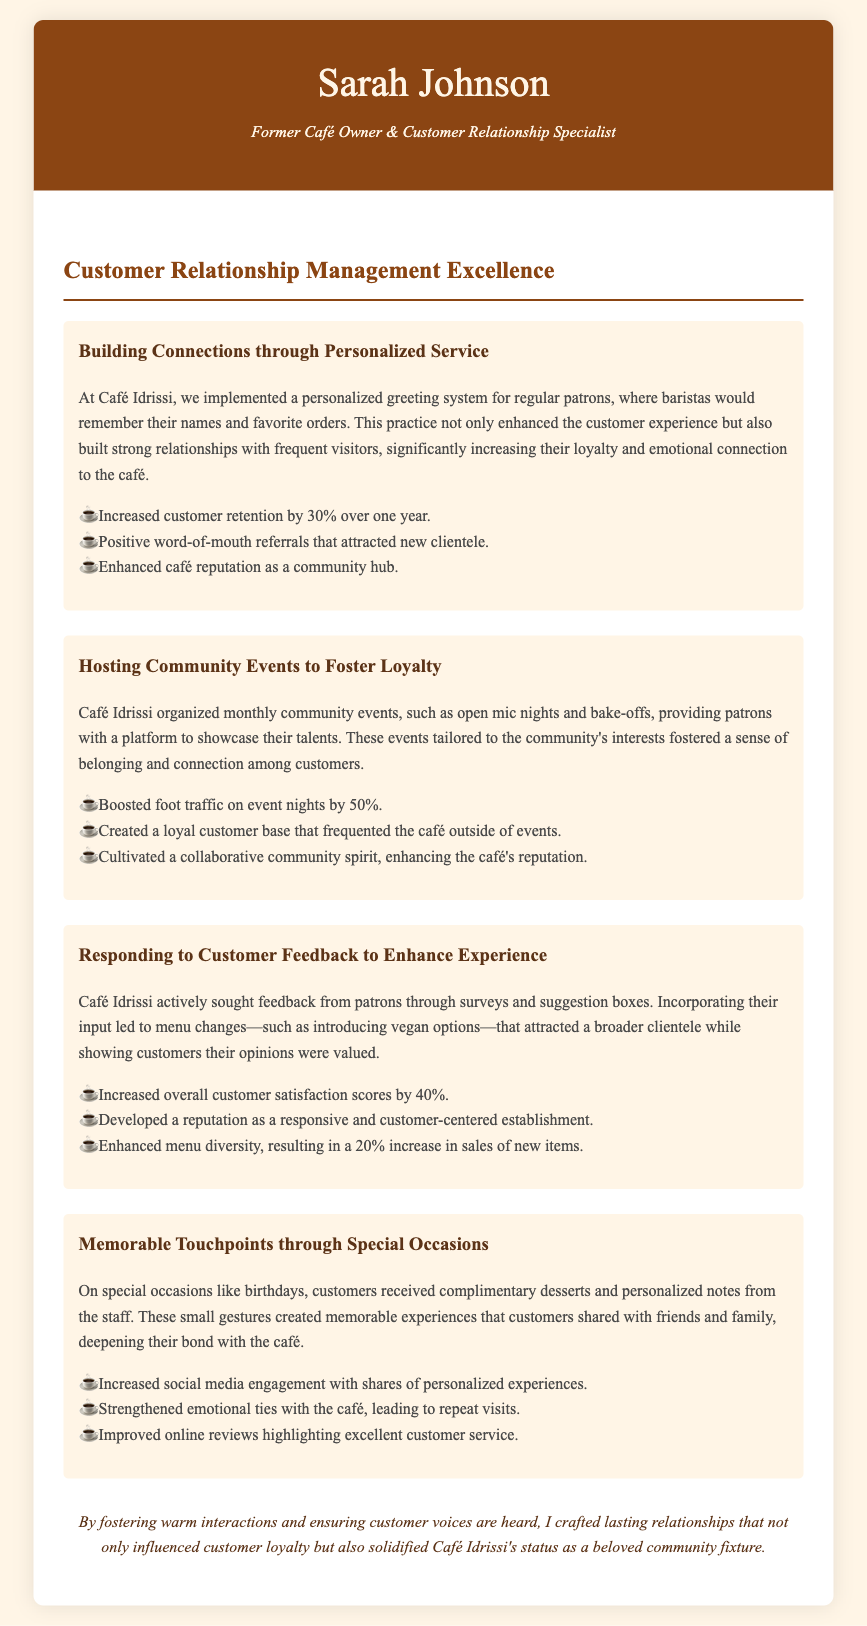what is the name of the café? The name of the café mentioned in the document is Café Idrissi.
Answer: Café Idrissi how much did customer retention increase by? The document states that customer retention increased by 30% over one year.
Answer: 30% what type of events were hosted to foster loyalty? The document mentions hosting monthly community events such as open mic nights and bake-offs.
Answer: open mic nights and bake-offs by how much did foot traffic boost on event nights? The document indicates that foot traffic on event nights was boosted by 50%.
Answer: 50% what was introduced to attract a broader clientele? The document states that vegan options were introduced to attract a broader clientele.
Answer: vegan options what did customers receive on special occasions? On special occasions, customers received complimentary desserts and personalized notes from staff.
Answer: complimentary desserts and personalized notes how much did overall customer satisfaction scores increase by? The document mentions that overall customer satisfaction scores increased by 40%.
Answer: 40% what was a goal of seeking customer feedback? The goal of seeking customer feedback was to incorporate their input and show customers their opinions were valued.
Answer: to incorporate their input what was the overall impact of personal connections on the café's reputation? The document concludes that personal connections solidified Café Idrissi's status as a beloved community fixture.
Answer: beloved community fixture 